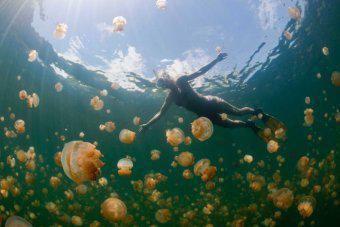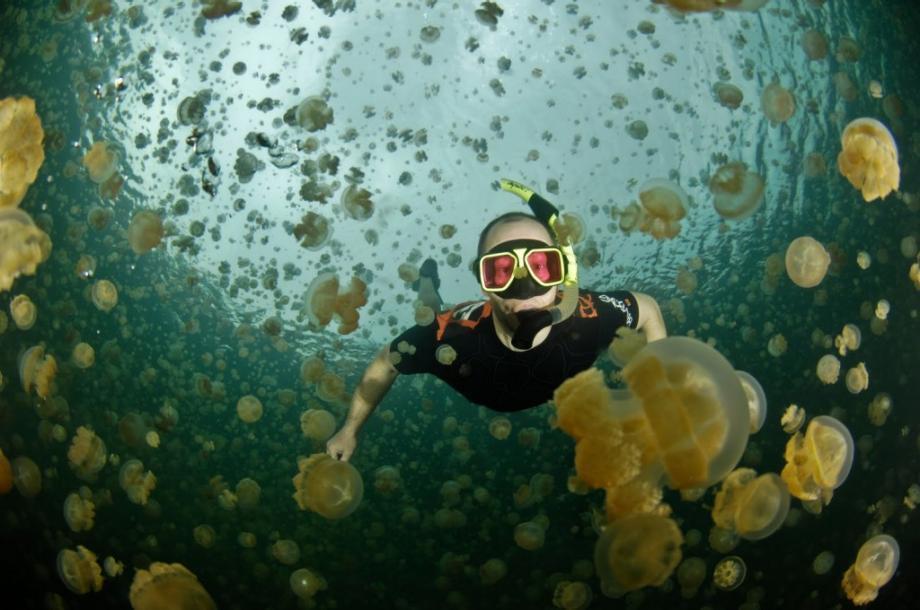The first image is the image on the left, the second image is the image on the right. Considering the images on both sides, is "There are two divers with the jellyfish." valid? Answer yes or no. Yes. The first image is the image on the left, the second image is the image on the right. Evaluate the accuracy of this statement regarding the images: "At least one of the people swimming is at least partially silhouetted against the sky.". Is it true? Answer yes or no. Yes. 